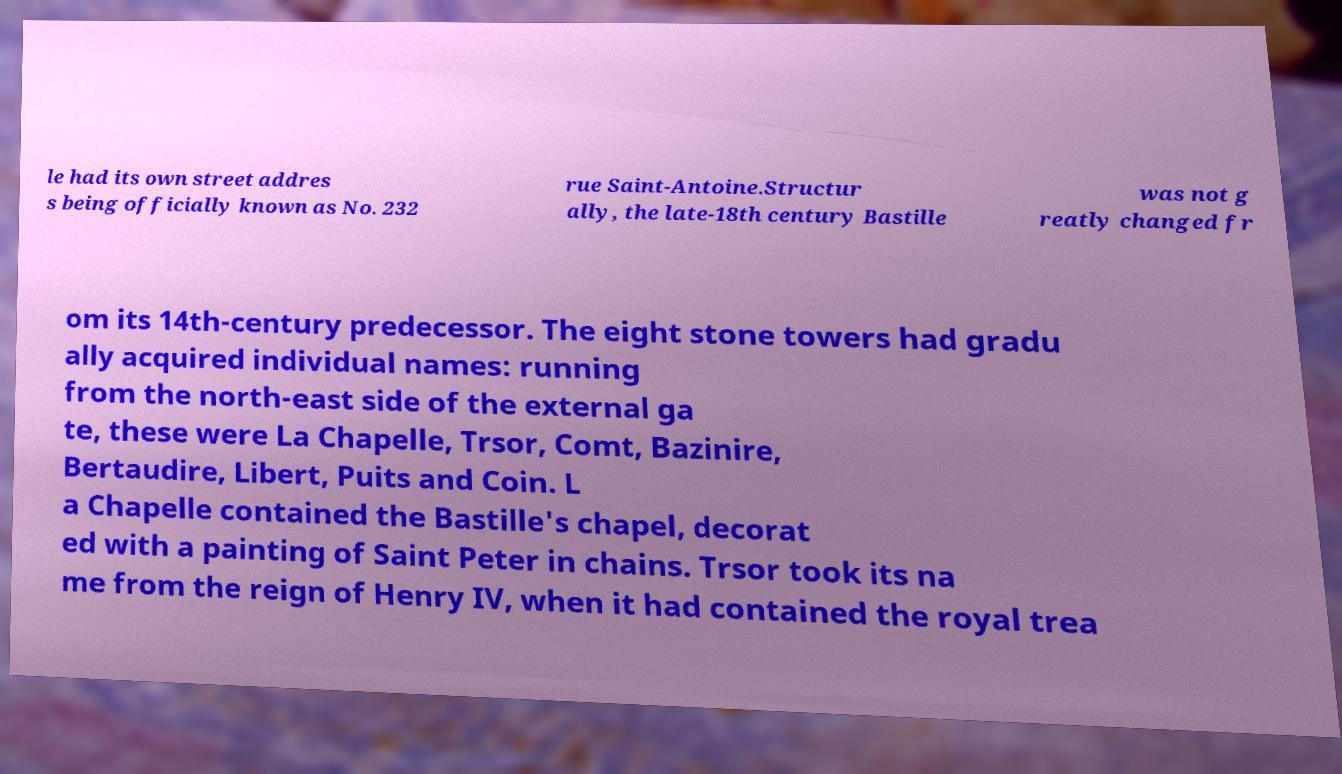I need the written content from this picture converted into text. Can you do that? le had its own street addres s being officially known as No. 232 rue Saint-Antoine.Structur ally, the late-18th century Bastille was not g reatly changed fr om its 14th-century predecessor. The eight stone towers had gradu ally acquired individual names: running from the north-east side of the external ga te, these were La Chapelle, Trsor, Comt, Bazinire, Bertaudire, Libert, Puits and Coin. L a Chapelle contained the Bastille's chapel, decorat ed with a painting of Saint Peter in chains. Trsor took its na me from the reign of Henry IV, when it had contained the royal trea 